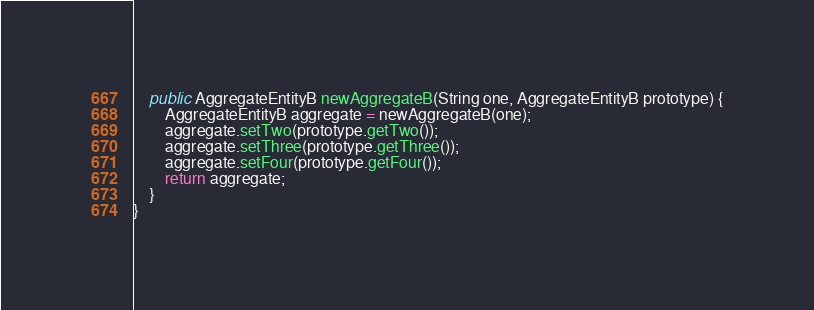Convert code to text. <code><loc_0><loc_0><loc_500><loc_500><_Java_>    public AggregateEntityB newAggregateB(String one, AggregateEntityB prototype) {
        AggregateEntityB aggregate = newAggregateB(one);
        aggregate.setTwo(prototype.getTwo());
        aggregate.setThree(prototype.getThree());
        aggregate.setFour(prototype.getFour());
        return aggregate;
    }
}
</code> 